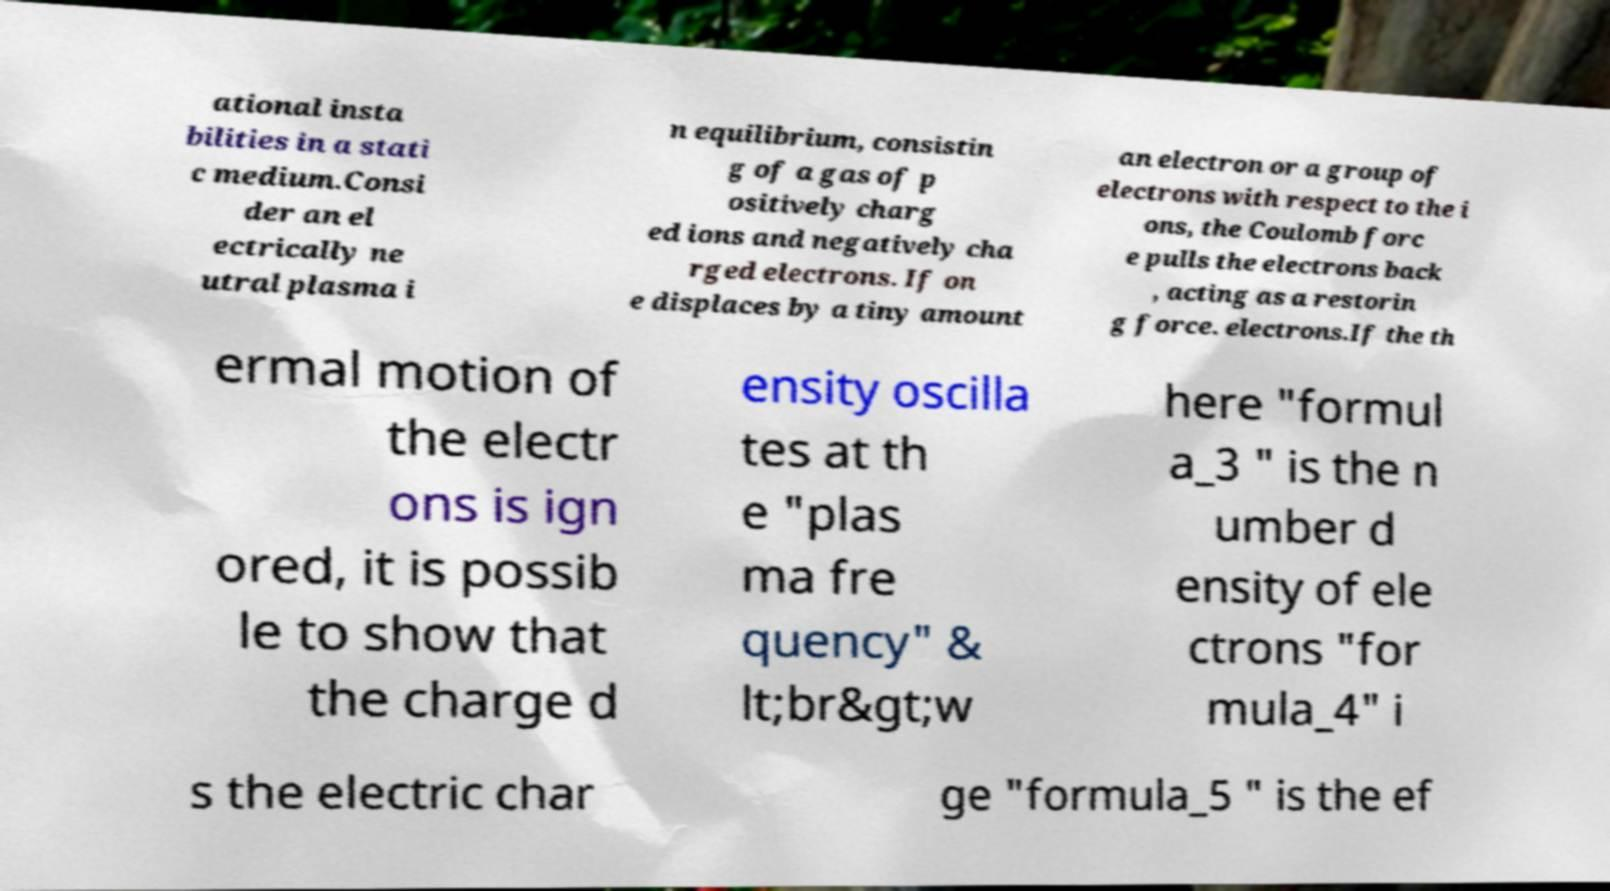Please identify and transcribe the text found in this image. ational insta bilities in a stati c medium.Consi der an el ectrically ne utral plasma i n equilibrium, consistin g of a gas of p ositively charg ed ions and negatively cha rged electrons. If on e displaces by a tiny amount an electron or a group of electrons with respect to the i ons, the Coulomb forc e pulls the electrons back , acting as a restorin g force. electrons.If the th ermal motion of the electr ons is ign ored, it is possib le to show that the charge d ensity oscilla tes at th e "plas ma fre quency" & lt;br&gt;w here "formul a_3 " is the n umber d ensity of ele ctrons "for mula_4" i s the electric char ge "formula_5 " is the ef 